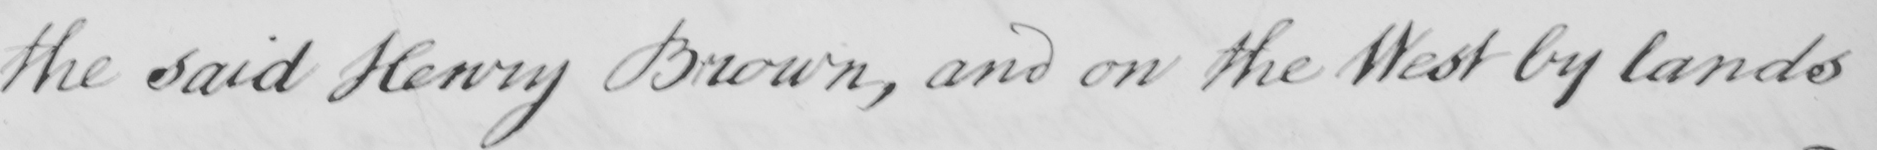Can you read and transcribe this handwriting? the said Henry Brown , and on the West by lands 